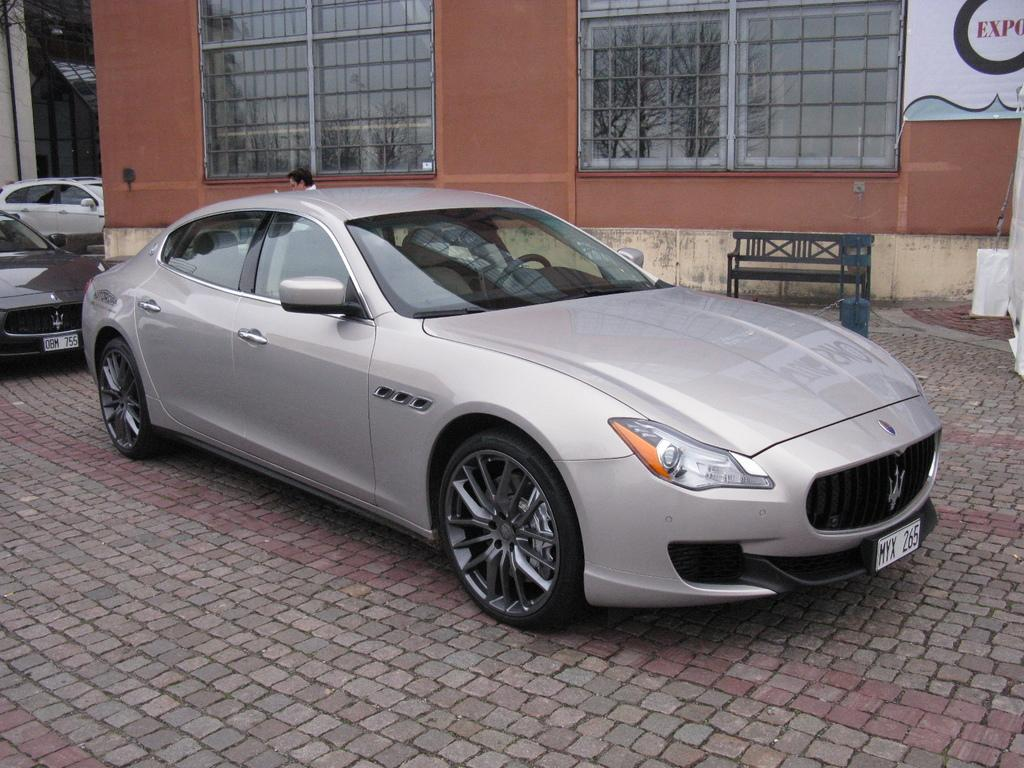What types of objects are present in the image? There are vehicles, a person, a bench, and a building in the image. Can you describe the person in the image? A person is standing in the image. What is the purpose of the bench in the image? The bench is a place for people to sit and rest. What type of structure is depicted in the image? There is a building in the image. Is there a mailbox visible in the image? There is no mention of a mailbox in the provided facts, so we cannot determine if one is present in the image. Can you describe the person's attempt to climb the building in the image? There is no indication in the provided facts that the person is attempting to climb the building, so we cannot answer this question. 